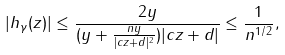Convert formula to latex. <formula><loc_0><loc_0><loc_500><loc_500>| h _ { \gamma } ( z ) | \leq \frac { 2 y } { ( y + \frac { n y } { | c z + d | ^ { 2 } } ) | c z + d | } \leq \frac { 1 } { n ^ { 1 / 2 } } ,</formula> 